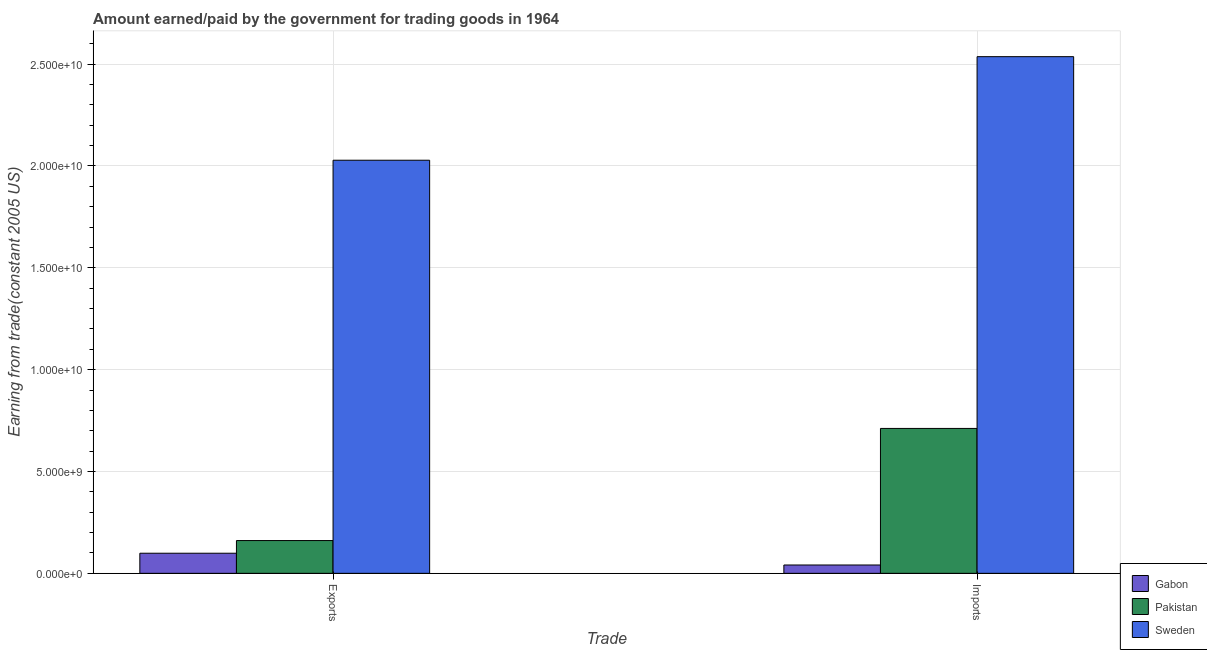Are the number of bars per tick equal to the number of legend labels?
Give a very brief answer. Yes. Are the number of bars on each tick of the X-axis equal?
Offer a terse response. Yes. What is the label of the 2nd group of bars from the left?
Ensure brevity in your answer.  Imports. What is the amount paid for imports in Pakistan?
Make the answer very short. 7.11e+09. Across all countries, what is the maximum amount paid for imports?
Offer a terse response. 2.54e+1. Across all countries, what is the minimum amount earned from exports?
Keep it short and to the point. 9.87e+08. In which country was the amount paid for imports maximum?
Ensure brevity in your answer.  Sweden. In which country was the amount earned from exports minimum?
Your answer should be compact. Gabon. What is the total amount earned from exports in the graph?
Offer a very short reply. 2.29e+1. What is the difference between the amount paid for imports in Sweden and that in Gabon?
Your answer should be very brief. 2.50e+1. What is the difference between the amount earned from exports in Sweden and the amount paid for imports in Gabon?
Provide a succinct answer. 1.99e+1. What is the average amount earned from exports per country?
Offer a very short reply. 7.63e+09. What is the difference between the amount paid for imports and amount earned from exports in Pakistan?
Your answer should be very brief. 5.51e+09. What is the ratio of the amount paid for imports in Pakistan to that in Gabon?
Ensure brevity in your answer.  17.38. In how many countries, is the amount earned from exports greater than the average amount earned from exports taken over all countries?
Give a very brief answer. 1. What does the 1st bar from the left in Exports represents?
Provide a short and direct response. Gabon. Are the values on the major ticks of Y-axis written in scientific E-notation?
Provide a succinct answer. Yes. Does the graph contain grids?
Ensure brevity in your answer.  Yes. What is the title of the graph?
Offer a very short reply. Amount earned/paid by the government for trading goods in 1964. Does "Bangladesh" appear as one of the legend labels in the graph?
Your response must be concise. No. What is the label or title of the X-axis?
Offer a terse response. Trade. What is the label or title of the Y-axis?
Give a very brief answer. Earning from trade(constant 2005 US). What is the Earning from trade(constant 2005 US) of Gabon in Exports?
Keep it short and to the point. 9.87e+08. What is the Earning from trade(constant 2005 US) of Pakistan in Exports?
Your answer should be compact. 1.61e+09. What is the Earning from trade(constant 2005 US) of Sweden in Exports?
Provide a succinct answer. 2.03e+1. What is the Earning from trade(constant 2005 US) in Gabon in Imports?
Ensure brevity in your answer.  4.09e+08. What is the Earning from trade(constant 2005 US) of Pakistan in Imports?
Keep it short and to the point. 7.11e+09. What is the Earning from trade(constant 2005 US) in Sweden in Imports?
Make the answer very short. 2.54e+1. Across all Trade, what is the maximum Earning from trade(constant 2005 US) of Gabon?
Your response must be concise. 9.87e+08. Across all Trade, what is the maximum Earning from trade(constant 2005 US) of Pakistan?
Offer a very short reply. 7.11e+09. Across all Trade, what is the maximum Earning from trade(constant 2005 US) of Sweden?
Provide a succinct answer. 2.54e+1. Across all Trade, what is the minimum Earning from trade(constant 2005 US) in Gabon?
Your answer should be compact. 4.09e+08. Across all Trade, what is the minimum Earning from trade(constant 2005 US) of Pakistan?
Offer a terse response. 1.61e+09. Across all Trade, what is the minimum Earning from trade(constant 2005 US) of Sweden?
Ensure brevity in your answer.  2.03e+1. What is the total Earning from trade(constant 2005 US) of Gabon in the graph?
Make the answer very short. 1.40e+09. What is the total Earning from trade(constant 2005 US) of Pakistan in the graph?
Keep it short and to the point. 8.72e+09. What is the total Earning from trade(constant 2005 US) of Sweden in the graph?
Ensure brevity in your answer.  4.56e+1. What is the difference between the Earning from trade(constant 2005 US) in Gabon in Exports and that in Imports?
Your response must be concise. 5.78e+08. What is the difference between the Earning from trade(constant 2005 US) in Pakistan in Exports and that in Imports?
Your answer should be compact. -5.51e+09. What is the difference between the Earning from trade(constant 2005 US) in Sweden in Exports and that in Imports?
Make the answer very short. -5.08e+09. What is the difference between the Earning from trade(constant 2005 US) of Gabon in Exports and the Earning from trade(constant 2005 US) of Pakistan in Imports?
Offer a very short reply. -6.13e+09. What is the difference between the Earning from trade(constant 2005 US) in Gabon in Exports and the Earning from trade(constant 2005 US) in Sweden in Imports?
Your answer should be very brief. -2.44e+1. What is the difference between the Earning from trade(constant 2005 US) in Pakistan in Exports and the Earning from trade(constant 2005 US) in Sweden in Imports?
Your answer should be compact. -2.38e+1. What is the average Earning from trade(constant 2005 US) in Gabon per Trade?
Ensure brevity in your answer.  6.98e+08. What is the average Earning from trade(constant 2005 US) in Pakistan per Trade?
Your answer should be very brief. 4.36e+09. What is the average Earning from trade(constant 2005 US) of Sweden per Trade?
Offer a very short reply. 2.28e+1. What is the difference between the Earning from trade(constant 2005 US) of Gabon and Earning from trade(constant 2005 US) of Pakistan in Exports?
Offer a terse response. -6.22e+08. What is the difference between the Earning from trade(constant 2005 US) of Gabon and Earning from trade(constant 2005 US) of Sweden in Exports?
Your response must be concise. -1.93e+1. What is the difference between the Earning from trade(constant 2005 US) of Pakistan and Earning from trade(constant 2005 US) of Sweden in Exports?
Your answer should be very brief. -1.87e+1. What is the difference between the Earning from trade(constant 2005 US) of Gabon and Earning from trade(constant 2005 US) of Pakistan in Imports?
Your answer should be very brief. -6.70e+09. What is the difference between the Earning from trade(constant 2005 US) of Gabon and Earning from trade(constant 2005 US) of Sweden in Imports?
Keep it short and to the point. -2.50e+1. What is the difference between the Earning from trade(constant 2005 US) in Pakistan and Earning from trade(constant 2005 US) in Sweden in Imports?
Provide a short and direct response. -1.83e+1. What is the ratio of the Earning from trade(constant 2005 US) of Gabon in Exports to that in Imports?
Ensure brevity in your answer.  2.41. What is the ratio of the Earning from trade(constant 2005 US) of Pakistan in Exports to that in Imports?
Offer a very short reply. 0.23. What is the ratio of the Earning from trade(constant 2005 US) of Sweden in Exports to that in Imports?
Your response must be concise. 0.8. What is the difference between the highest and the second highest Earning from trade(constant 2005 US) of Gabon?
Give a very brief answer. 5.78e+08. What is the difference between the highest and the second highest Earning from trade(constant 2005 US) in Pakistan?
Offer a terse response. 5.51e+09. What is the difference between the highest and the second highest Earning from trade(constant 2005 US) in Sweden?
Give a very brief answer. 5.08e+09. What is the difference between the highest and the lowest Earning from trade(constant 2005 US) in Gabon?
Make the answer very short. 5.78e+08. What is the difference between the highest and the lowest Earning from trade(constant 2005 US) in Pakistan?
Your response must be concise. 5.51e+09. What is the difference between the highest and the lowest Earning from trade(constant 2005 US) of Sweden?
Provide a short and direct response. 5.08e+09. 